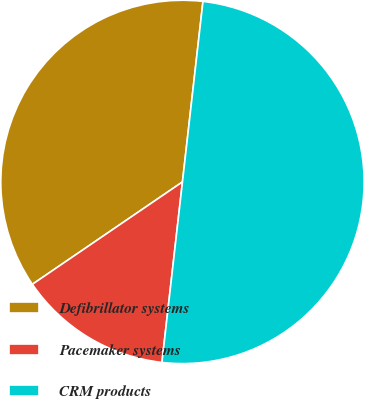Convert chart to OTSL. <chart><loc_0><loc_0><loc_500><loc_500><pie_chart><fcel>Defibrillator systems<fcel>Pacemaker systems<fcel>CRM products<nl><fcel>36.33%<fcel>13.67%<fcel>50.0%<nl></chart> 